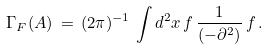Convert formula to latex. <formula><loc_0><loc_0><loc_500><loc_500>\Gamma _ { F } ( A ) \, = \, ( 2 \pi ) ^ { - 1 } \, \int d ^ { 2 } x \, f \, \frac { 1 } { ( - \partial ^ { 2 } ) } \, f \, .</formula> 